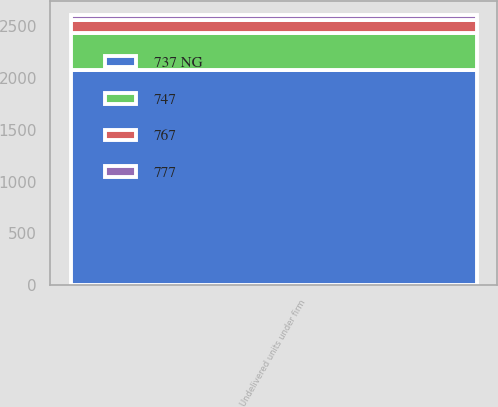<chart> <loc_0><loc_0><loc_500><loc_500><stacked_bar_chart><ecel><fcel>Undelivered units under firm<nl><fcel>737 NG<fcel>2076<nl><fcel>767<fcel>125<nl><fcel>777<fcel>52<nl><fcel>747<fcel>357<nl></chart> 